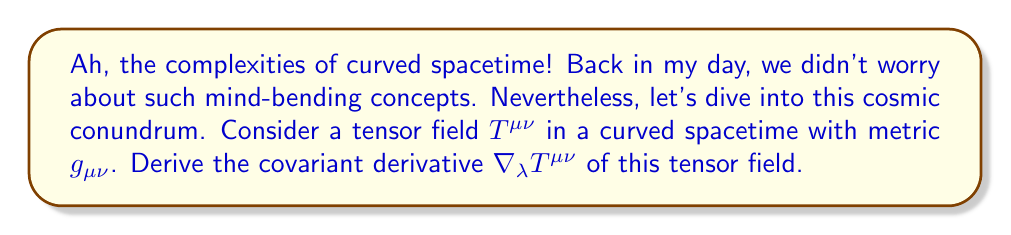Solve this math problem. Let's approach this step-by-step, just like we used to solve puzzles in the good old days:

1) The covariant derivative of a tensor field in curved spacetime is given by:

   $$\nabla_\lambda T^{\mu\nu} = \partial_\lambda T^{\mu\nu} + \Gamma^{\mu}_{\lambda\sigma}T^{\sigma\nu} + \Gamma^{\nu}_{\lambda\sigma}T^{\mu\sigma}$$

2) Here, $\partial_\lambda T^{\mu\nu}$ is the partial derivative, and $\Gamma^{\mu}_{\lambda\sigma}$ are the Christoffel symbols.

3) The Christoffel symbols are defined in terms of the metric:

   $$\Gamma^{\mu}_{\lambda\sigma} = \frac{1}{2}g^{\mu\rho}(\partial_\lambda g_{\sigma\rho} + \partial_\sigma g_{\lambda\rho} - \partial_\rho g_{\lambda\sigma})$$

4) To fully derive the covariant derivative, we need to:
   a) Calculate the partial derivative $\partial_\lambda T^{\mu\nu}$
   b) Determine the Christoffel symbols $\Gamma^{\mu}_{\lambda\sigma}$
   c) Sum the terms as in step 1

5) The result will depend on the specific form of $T^{\mu\nu}$ and the metric $g_{\mu\nu}$.

6) Remember, this expression accounts for the curvature of spacetime, something we didn't consider in classical physics!
Answer: $$\nabla_\lambda T^{\mu\nu} = \partial_\lambda T^{\mu\nu} + \Gamma^{\mu}_{\lambda\sigma}T^{\sigma\nu} + \Gamma^{\nu}_{\lambda\sigma}T^{\mu\sigma}$$ 